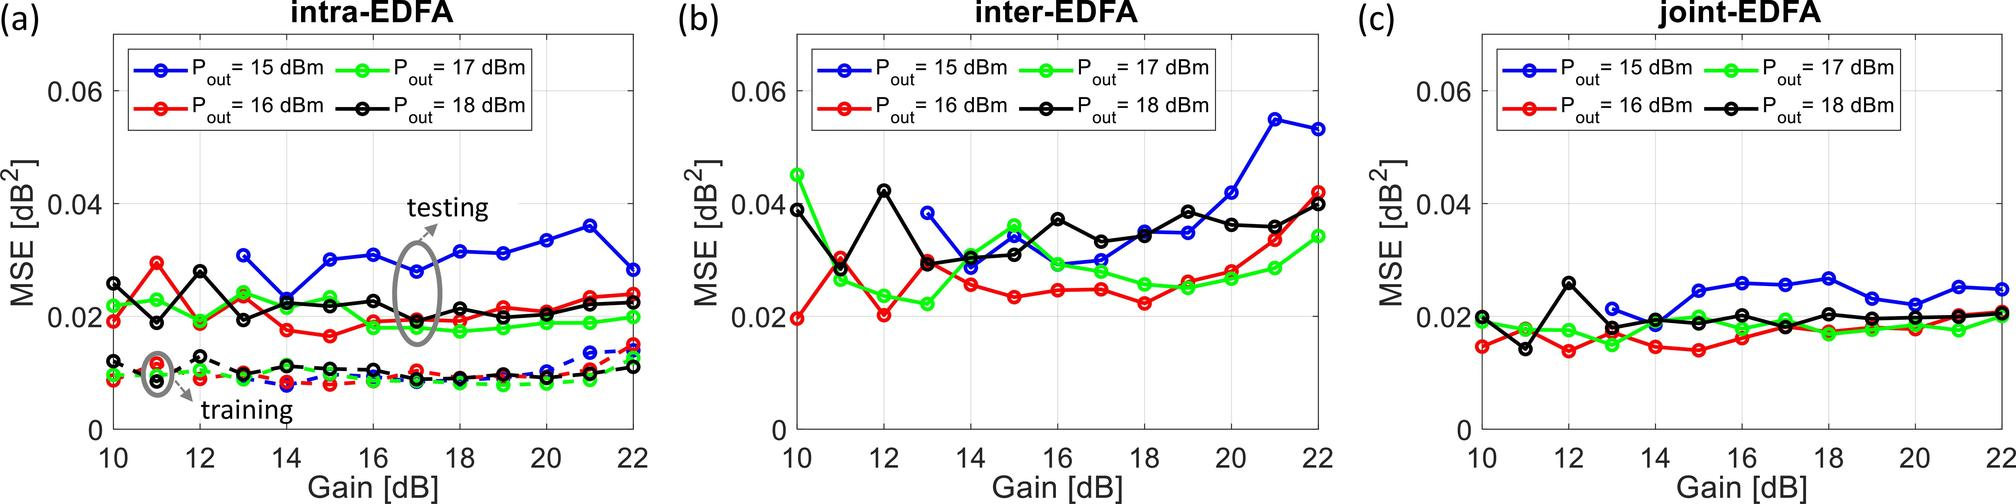What can be inferred about the efficiency of the intra-EDFA configuration with respect to the different output powers based on Figure (a)? Analyzing Figure (a), it is possible to infer that the intra-EDFA configuration operates with variable efficiency across different output power levels. As we can observe, the reduction in MSE as the gain increases suggests that the system's efficiency improves up to a certain point. This optimum is reached at a gain level of around 16 dB for all the output powers examined. Beyond this gain value, increasing the gain further does not significantly affect the MSE, indicating that the efficiency of the intra-EDFA in reducing MSE does not improve substantially, and the system is operating in an efficient but stable state within the range of depicted output powers. 